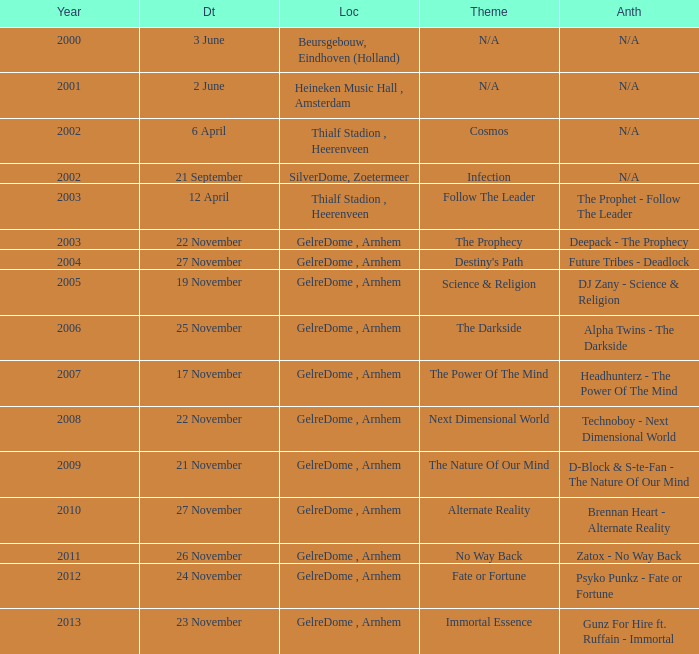What is the earliest year it was located in gelredome, arnhem, and a Anthem of technoboy - next dimensional world? 2008.0. 